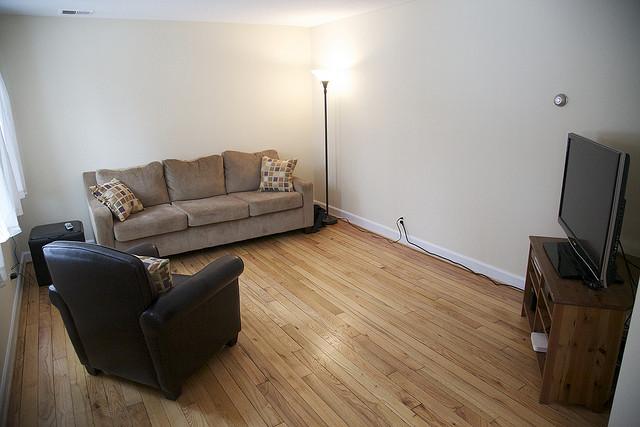Is the ottoman the same color as the other furniture?
Write a very short answer. No. Is this a living room?
Be succinct. Yes. What is the floor made of?
Keep it brief. Wood. Are there any framed pieces on the walls?
Answer briefly. No. Is there a television in this room?
Concise answer only. Yes. Is the light on or off?
Write a very short answer. On. 